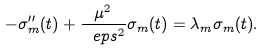<formula> <loc_0><loc_0><loc_500><loc_500>- \sigma _ { m } ^ { \prime \prime } ( t ) + \frac { \mu ^ { 2 } } { \ e p s ^ { 2 } } \sigma _ { m } ( t ) = \lambda _ { m } \sigma _ { m } ( t ) .</formula> 